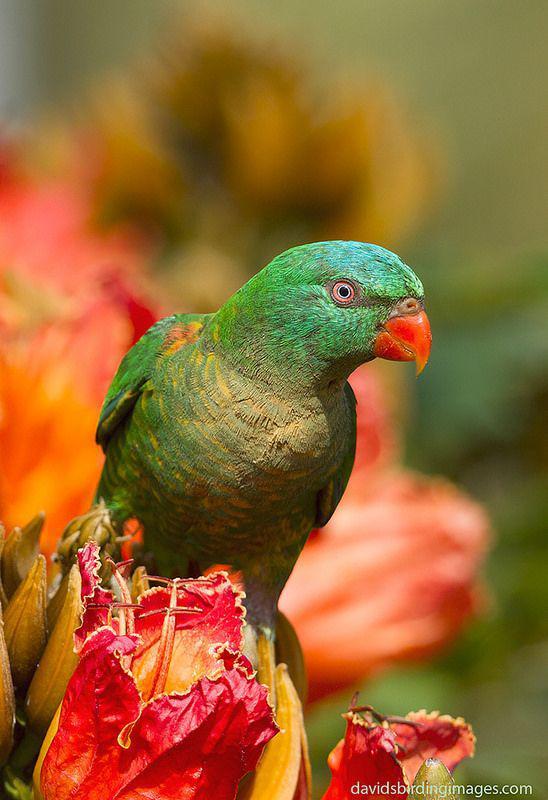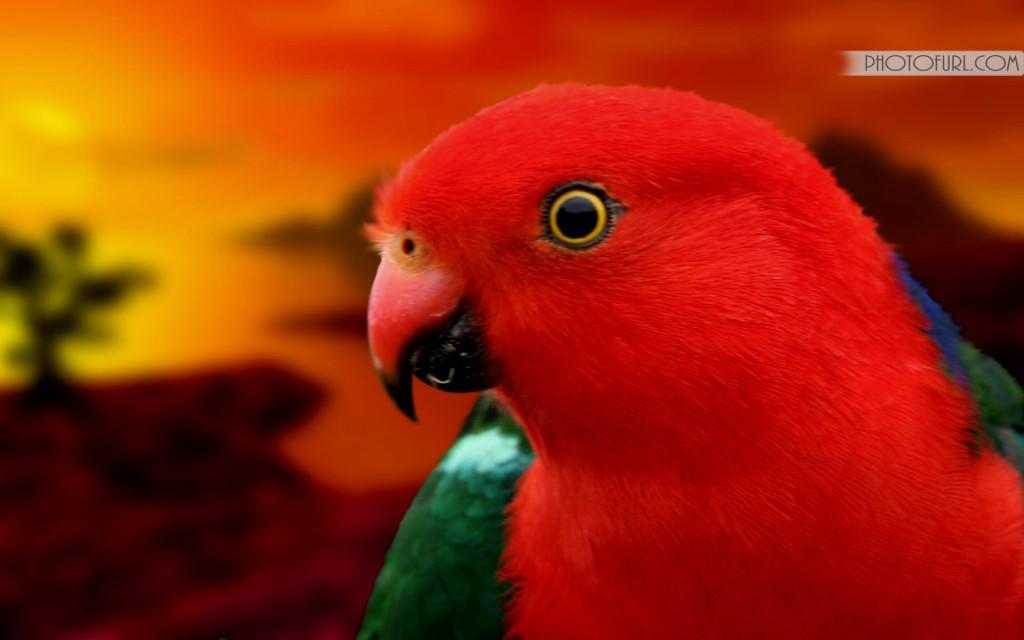The first image is the image on the left, the second image is the image on the right. Evaluate the accuracy of this statement regarding the images: "All parrots have green body feathers and red beaks.". Is it true? Answer yes or no. No. The first image is the image on the left, the second image is the image on the right. Given the left and right images, does the statement "There is exactly one bird in the iamge on the right" hold true? Answer yes or no. Yes. 